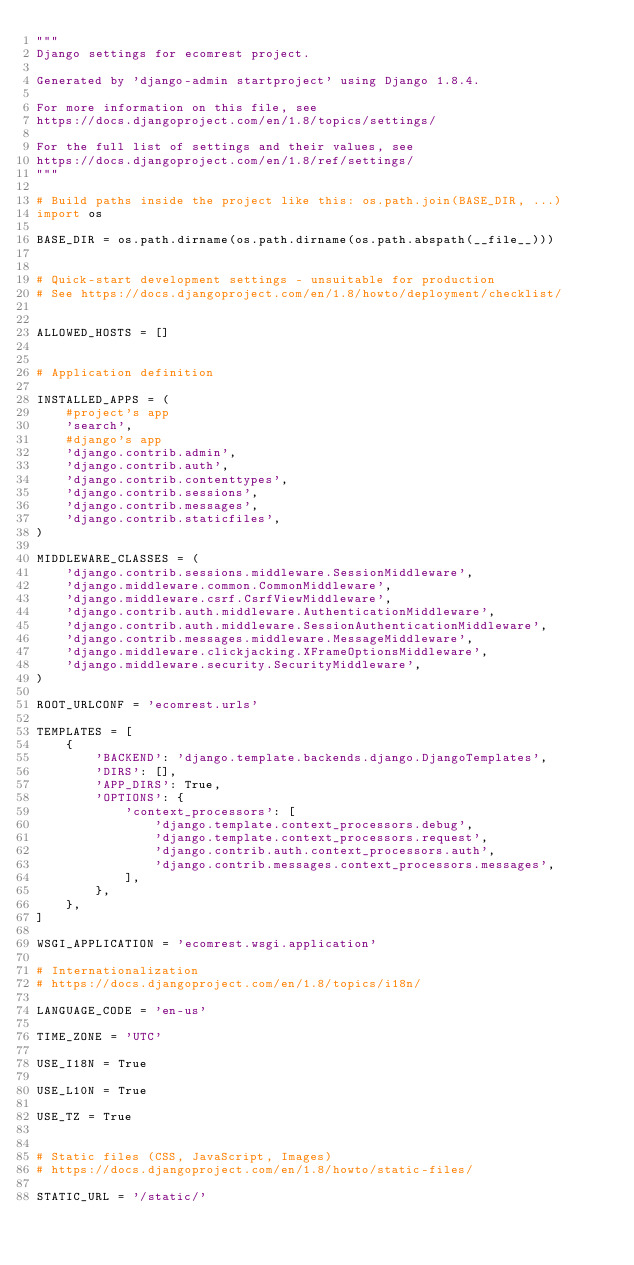<code> <loc_0><loc_0><loc_500><loc_500><_Python_>"""
Django settings for ecomrest project.

Generated by 'django-admin startproject' using Django 1.8.4.

For more information on this file, see
https://docs.djangoproject.com/en/1.8/topics/settings/

For the full list of settings and their values, see
https://docs.djangoproject.com/en/1.8/ref/settings/
"""

# Build paths inside the project like this: os.path.join(BASE_DIR, ...)
import os

BASE_DIR = os.path.dirname(os.path.dirname(os.path.abspath(__file__)))


# Quick-start development settings - unsuitable for production
# See https://docs.djangoproject.com/en/1.8/howto/deployment/checklist/


ALLOWED_HOSTS = []


# Application definition

INSTALLED_APPS = (
    #project's app
    'search',
    #django's app
    'django.contrib.admin',
    'django.contrib.auth',
    'django.contrib.contenttypes',
    'django.contrib.sessions',
    'django.contrib.messages',
    'django.contrib.staticfiles',
)

MIDDLEWARE_CLASSES = (
    'django.contrib.sessions.middleware.SessionMiddleware',
    'django.middleware.common.CommonMiddleware',
    'django.middleware.csrf.CsrfViewMiddleware',
    'django.contrib.auth.middleware.AuthenticationMiddleware',
    'django.contrib.auth.middleware.SessionAuthenticationMiddleware',
    'django.contrib.messages.middleware.MessageMiddleware',
    'django.middleware.clickjacking.XFrameOptionsMiddleware',
    'django.middleware.security.SecurityMiddleware',
)

ROOT_URLCONF = 'ecomrest.urls'

TEMPLATES = [
    {
        'BACKEND': 'django.template.backends.django.DjangoTemplates',
        'DIRS': [],
        'APP_DIRS': True,
        'OPTIONS': {
            'context_processors': [
                'django.template.context_processors.debug',
                'django.template.context_processors.request',
                'django.contrib.auth.context_processors.auth',
                'django.contrib.messages.context_processors.messages',
            ],
        },
    },
]

WSGI_APPLICATION = 'ecomrest.wsgi.application'

# Internationalization
# https://docs.djangoproject.com/en/1.8/topics/i18n/

LANGUAGE_CODE = 'en-us'

TIME_ZONE = 'UTC'

USE_I18N = True

USE_L10N = True

USE_TZ = True


# Static files (CSS, JavaScript, Images)
# https://docs.djangoproject.com/en/1.8/howto/static-files/

STATIC_URL = '/static/'
</code> 